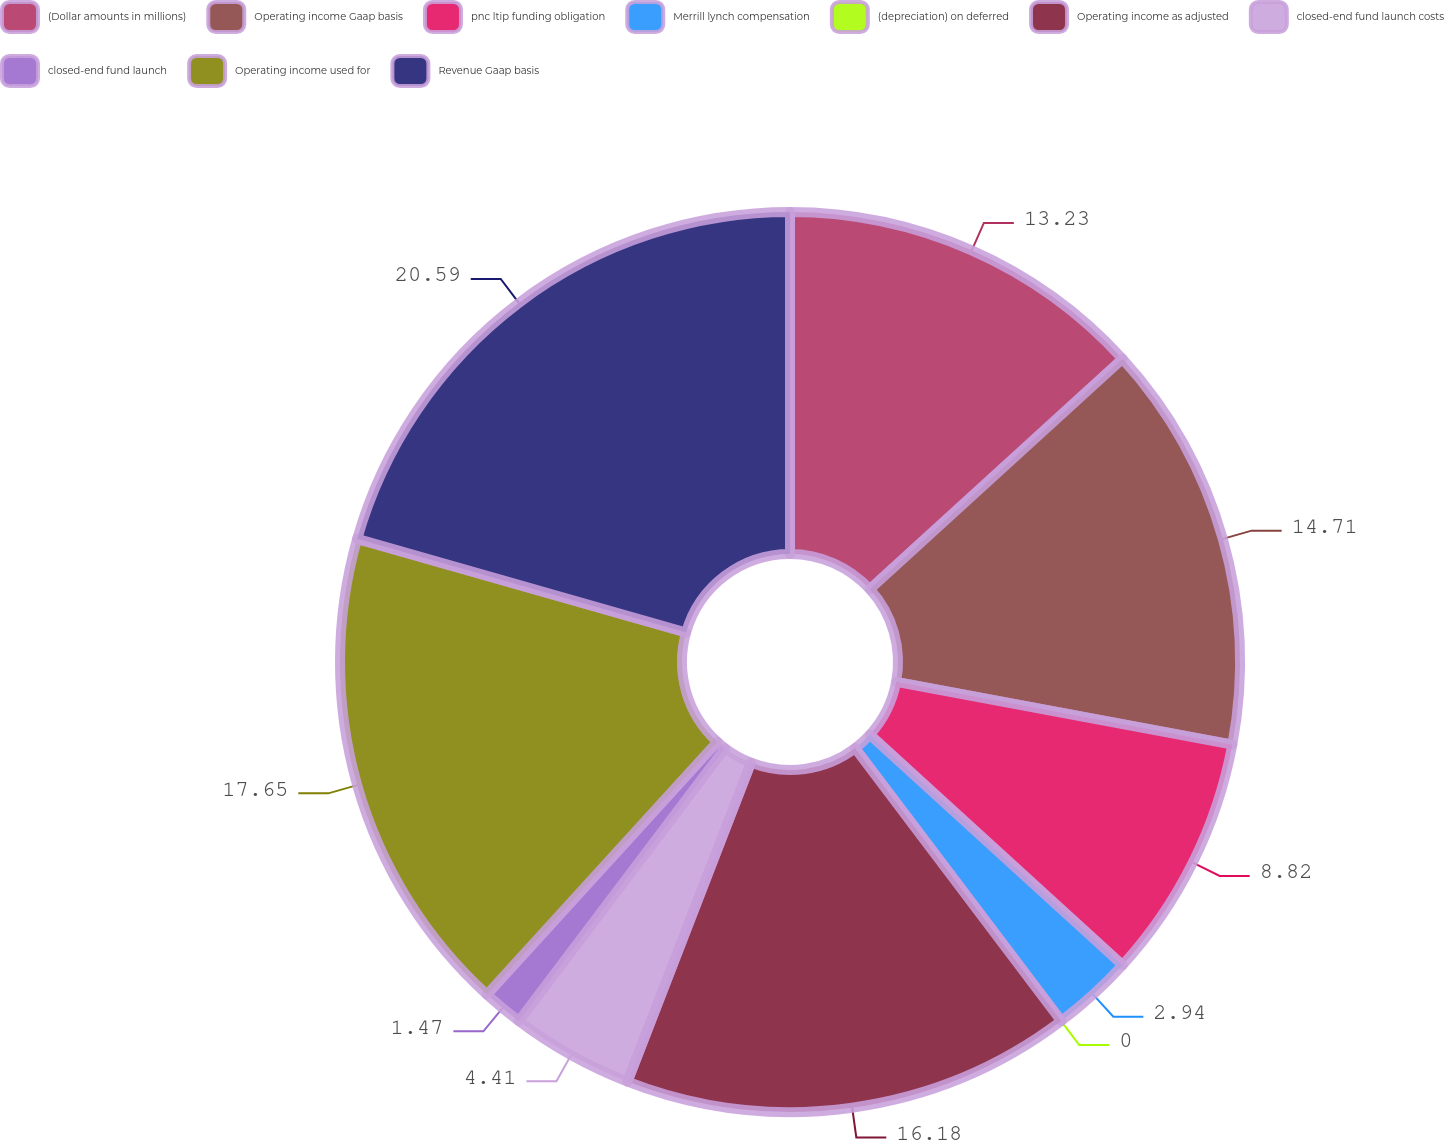<chart> <loc_0><loc_0><loc_500><loc_500><pie_chart><fcel>(Dollar amounts in millions)<fcel>Operating income Gaap basis<fcel>pnc ltip funding obligation<fcel>Merrill lynch compensation<fcel>(depreciation) on deferred<fcel>Operating income as adjusted<fcel>closed-end fund launch costs<fcel>closed-end fund launch<fcel>Operating income used for<fcel>Revenue Gaap basis<nl><fcel>13.23%<fcel>14.7%<fcel>8.82%<fcel>2.94%<fcel>0.0%<fcel>16.17%<fcel>4.41%<fcel>1.47%<fcel>17.64%<fcel>20.58%<nl></chart> 